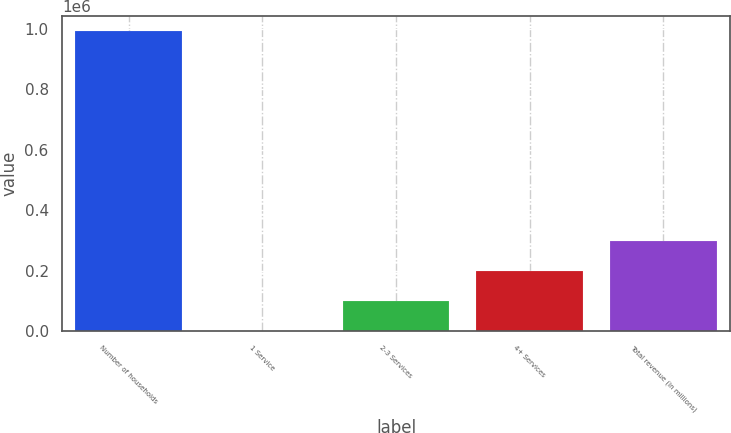Convert chart to OTSL. <chart><loc_0><loc_0><loc_500><loc_500><bar_chart><fcel>Number of households<fcel>1 Service<fcel>2-3 Services<fcel>4+ Services<fcel>Total revenue (in millions)<nl><fcel>993272<fcel>5.3<fcel>99332<fcel>198659<fcel>297985<nl></chart> 